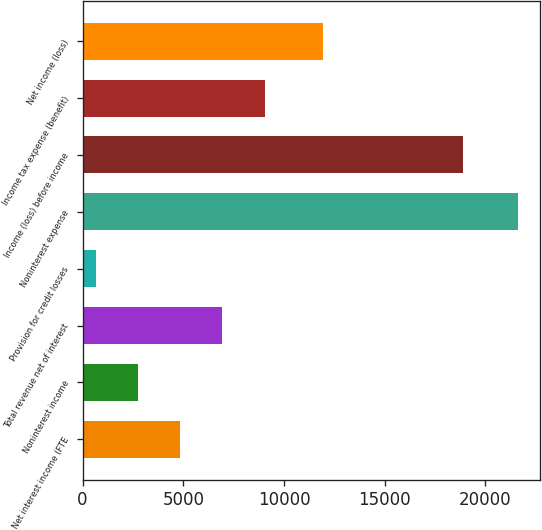Convert chart. <chart><loc_0><loc_0><loc_500><loc_500><bar_chart><fcel>Net interest income (FTE<fcel>Noninterest income<fcel>Total revenue net of interest<fcel>Provision for credit losses<fcel>Noninterest expense<fcel>Income (loss) before income<fcel>Income tax expense (benefit)<fcel>Net income (loss)<nl><fcel>4842.2<fcel>2743.1<fcel>6941.3<fcel>644<fcel>21635<fcel>18873<fcel>9040.4<fcel>11958<nl></chart> 